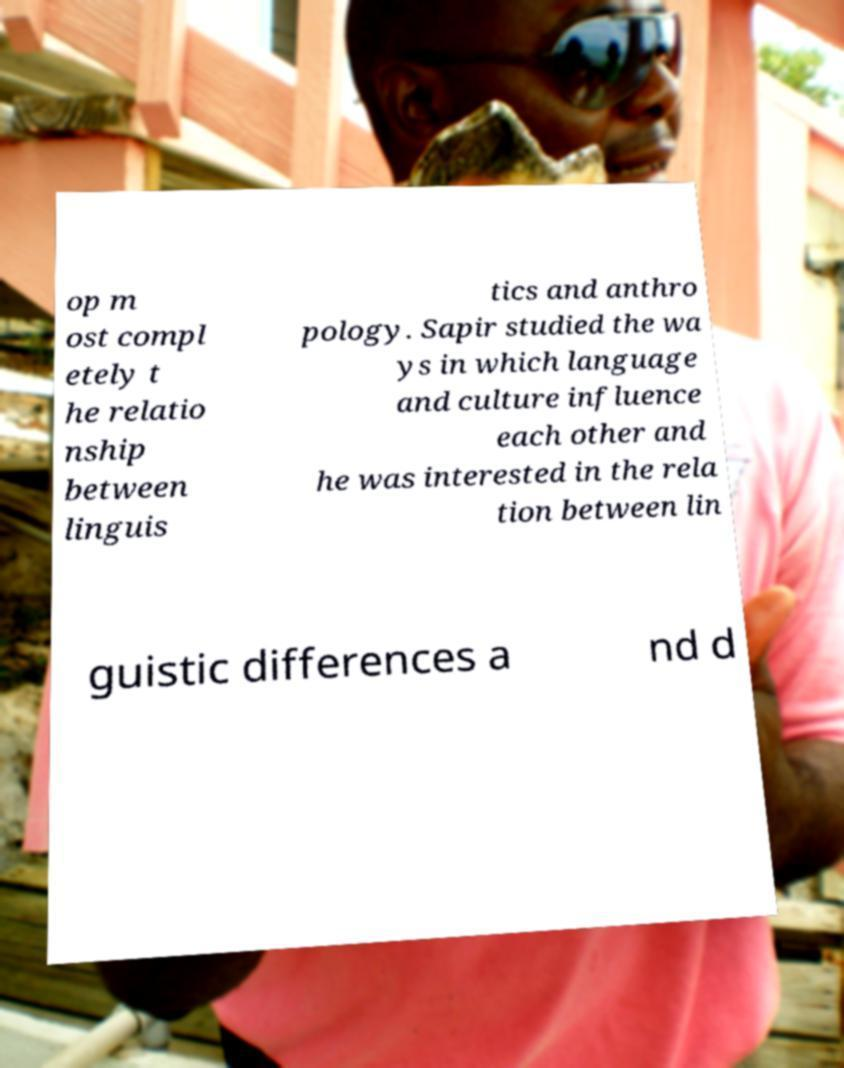Can you accurately transcribe the text from the provided image for me? op m ost compl etely t he relatio nship between linguis tics and anthro pology. Sapir studied the wa ys in which language and culture influence each other and he was interested in the rela tion between lin guistic differences a nd d 